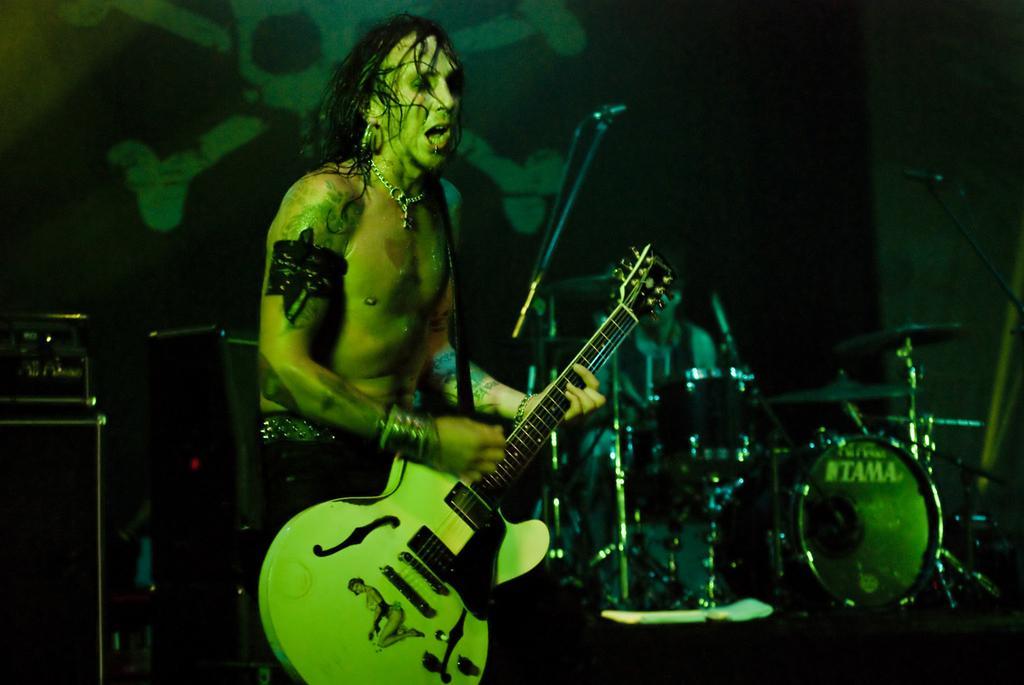Can you describe this image briefly? Here a man is playing guitar. Behind him there are few people playing musical instruments and a hoarding. 